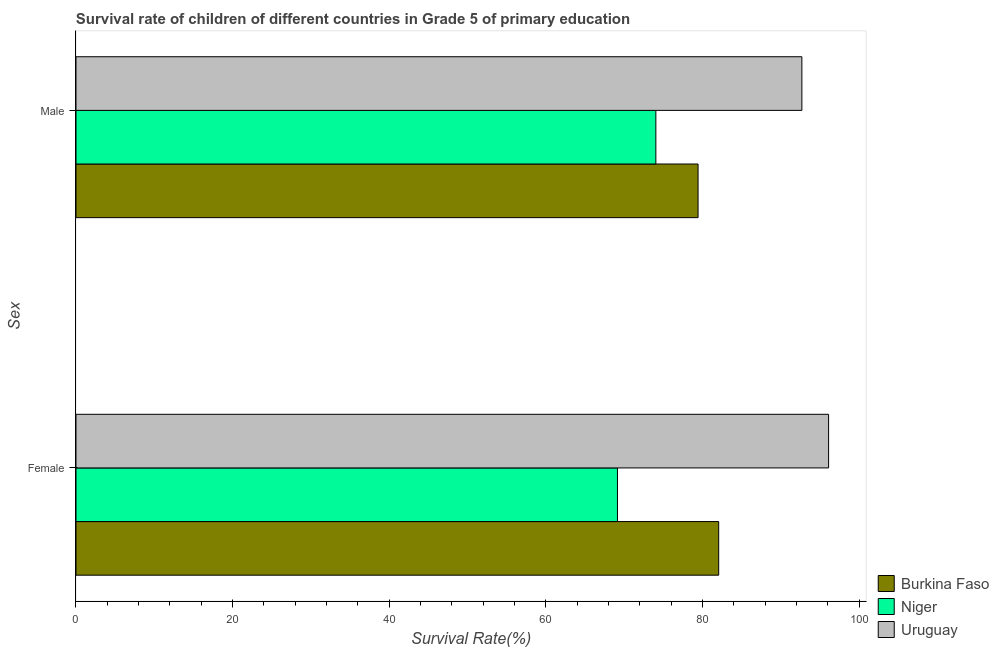Are the number of bars on each tick of the Y-axis equal?
Your response must be concise. Yes. What is the label of the 1st group of bars from the top?
Provide a short and direct response. Male. What is the survival rate of male students in primary education in Uruguay?
Provide a short and direct response. 92.69. Across all countries, what is the maximum survival rate of male students in primary education?
Offer a terse response. 92.69. Across all countries, what is the minimum survival rate of female students in primary education?
Provide a short and direct response. 69.14. In which country was the survival rate of male students in primary education maximum?
Provide a short and direct response. Uruguay. In which country was the survival rate of male students in primary education minimum?
Provide a short and direct response. Niger. What is the total survival rate of male students in primary education in the graph?
Your answer should be very brief. 246.18. What is the difference between the survival rate of female students in primary education in Niger and that in Burkina Faso?
Provide a succinct answer. -12.93. What is the difference between the survival rate of female students in primary education in Uruguay and the survival rate of male students in primary education in Burkina Faso?
Provide a succinct answer. 16.67. What is the average survival rate of male students in primary education per country?
Offer a very short reply. 82.06. What is the difference between the survival rate of female students in primary education and survival rate of male students in primary education in Uruguay?
Your response must be concise. 3.41. What is the ratio of the survival rate of male students in primary education in Niger to that in Burkina Faso?
Ensure brevity in your answer.  0.93. What does the 3rd bar from the top in Male represents?
Give a very brief answer. Burkina Faso. What does the 1st bar from the bottom in Male represents?
Keep it short and to the point. Burkina Faso. How many countries are there in the graph?
Offer a terse response. 3. Does the graph contain grids?
Give a very brief answer. No. Where does the legend appear in the graph?
Your answer should be very brief. Bottom right. How many legend labels are there?
Provide a short and direct response. 3. What is the title of the graph?
Make the answer very short. Survival rate of children of different countries in Grade 5 of primary education. Does "Nepal" appear as one of the legend labels in the graph?
Your response must be concise. No. What is the label or title of the X-axis?
Offer a very short reply. Survival Rate(%). What is the label or title of the Y-axis?
Ensure brevity in your answer.  Sex. What is the Survival Rate(%) of Burkina Faso in Female?
Provide a short and direct response. 82.07. What is the Survival Rate(%) in Niger in Female?
Provide a succinct answer. 69.14. What is the Survival Rate(%) in Uruguay in Female?
Give a very brief answer. 96.11. What is the Survival Rate(%) in Burkina Faso in Male?
Provide a succinct answer. 79.44. What is the Survival Rate(%) in Niger in Male?
Provide a short and direct response. 74.05. What is the Survival Rate(%) of Uruguay in Male?
Provide a succinct answer. 92.69. Across all Sex, what is the maximum Survival Rate(%) of Burkina Faso?
Offer a very short reply. 82.07. Across all Sex, what is the maximum Survival Rate(%) of Niger?
Offer a terse response. 74.05. Across all Sex, what is the maximum Survival Rate(%) of Uruguay?
Provide a succinct answer. 96.11. Across all Sex, what is the minimum Survival Rate(%) in Burkina Faso?
Ensure brevity in your answer.  79.44. Across all Sex, what is the minimum Survival Rate(%) in Niger?
Your answer should be very brief. 69.14. Across all Sex, what is the minimum Survival Rate(%) of Uruguay?
Ensure brevity in your answer.  92.69. What is the total Survival Rate(%) of Burkina Faso in the graph?
Ensure brevity in your answer.  161.51. What is the total Survival Rate(%) of Niger in the graph?
Offer a very short reply. 143.19. What is the total Survival Rate(%) in Uruguay in the graph?
Keep it short and to the point. 188.8. What is the difference between the Survival Rate(%) in Burkina Faso in Female and that in Male?
Offer a very short reply. 2.63. What is the difference between the Survival Rate(%) in Niger in Female and that in Male?
Your answer should be compact. -4.91. What is the difference between the Survival Rate(%) in Uruguay in Female and that in Male?
Make the answer very short. 3.41. What is the difference between the Survival Rate(%) of Burkina Faso in Female and the Survival Rate(%) of Niger in Male?
Offer a terse response. 8.02. What is the difference between the Survival Rate(%) of Burkina Faso in Female and the Survival Rate(%) of Uruguay in Male?
Offer a very short reply. -10.62. What is the difference between the Survival Rate(%) in Niger in Female and the Survival Rate(%) in Uruguay in Male?
Keep it short and to the point. -23.55. What is the average Survival Rate(%) in Burkina Faso per Sex?
Ensure brevity in your answer.  80.75. What is the average Survival Rate(%) in Niger per Sex?
Make the answer very short. 71.6. What is the average Survival Rate(%) of Uruguay per Sex?
Provide a short and direct response. 94.4. What is the difference between the Survival Rate(%) of Burkina Faso and Survival Rate(%) of Niger in Female?
Your response must be concise. 12.93. What is the difference between the Survival Rate(%) in Burkina Faso and Survival Rate(%) in Uruguay in Female?
Keep it short and to the point. -14.04. What is the difference between the Survival Rate(%) of Niger and Survival Rate(%) of Uruguay in Female?
Offer a very short reply. -26.96. What is the difference between the Survival Rate(%) in Burkina Faso and Survival Rate(%) in Niger in Male?
Offer a terse response. 5.39. What is the difference between the Survival Rate(%) in Burkina Faso and Survival Rate(%) in Uruguay in Male?
Provide a succinct answer. -13.26. What is the difference between the Survival Rate(%) in Niger and Survival Rate(%) in Uruguay in Male?
Provide a short and direct response. -18.64. What is the ratio of the Survival Rate(%) of Burkina Faso in Female to that in Male?
Ensure brevity in your answer.  1.03. What is the ratio of the Survival Rate(%) in Niger in Female to that in Male?
Your response must be concise. 0.93. What is the ratio of the Survival Rate(%) of Uruguay in Female to that in Male?
Provide a succinct answer. 1.04. What is the difference between the highest and the second highest Survival Rate(%) in Burkina Faso?
Ensure brevity in your answer.  2.63. What is the difference between the highest and the second highest Survival Rate(%) in Niger?
Make the answer very short. 4.91. What is the difference between the highest and the second highest Survival Rate(%) in Uruguay?
Keep it short and to the point. 3.41. What is the difference between the highest and the lowest Survival Rate(%) of Burkina Faso?
Provide a short and direct response. 2.63. What is the difference between the highest and the lowest Survival Rate(%) in Niger?
Provide a succinct answer. 4.91. What is the difference between the highest and the lowest Survival Rate(%) of Uruguay?
Your answer should be very brief. 3.41. 